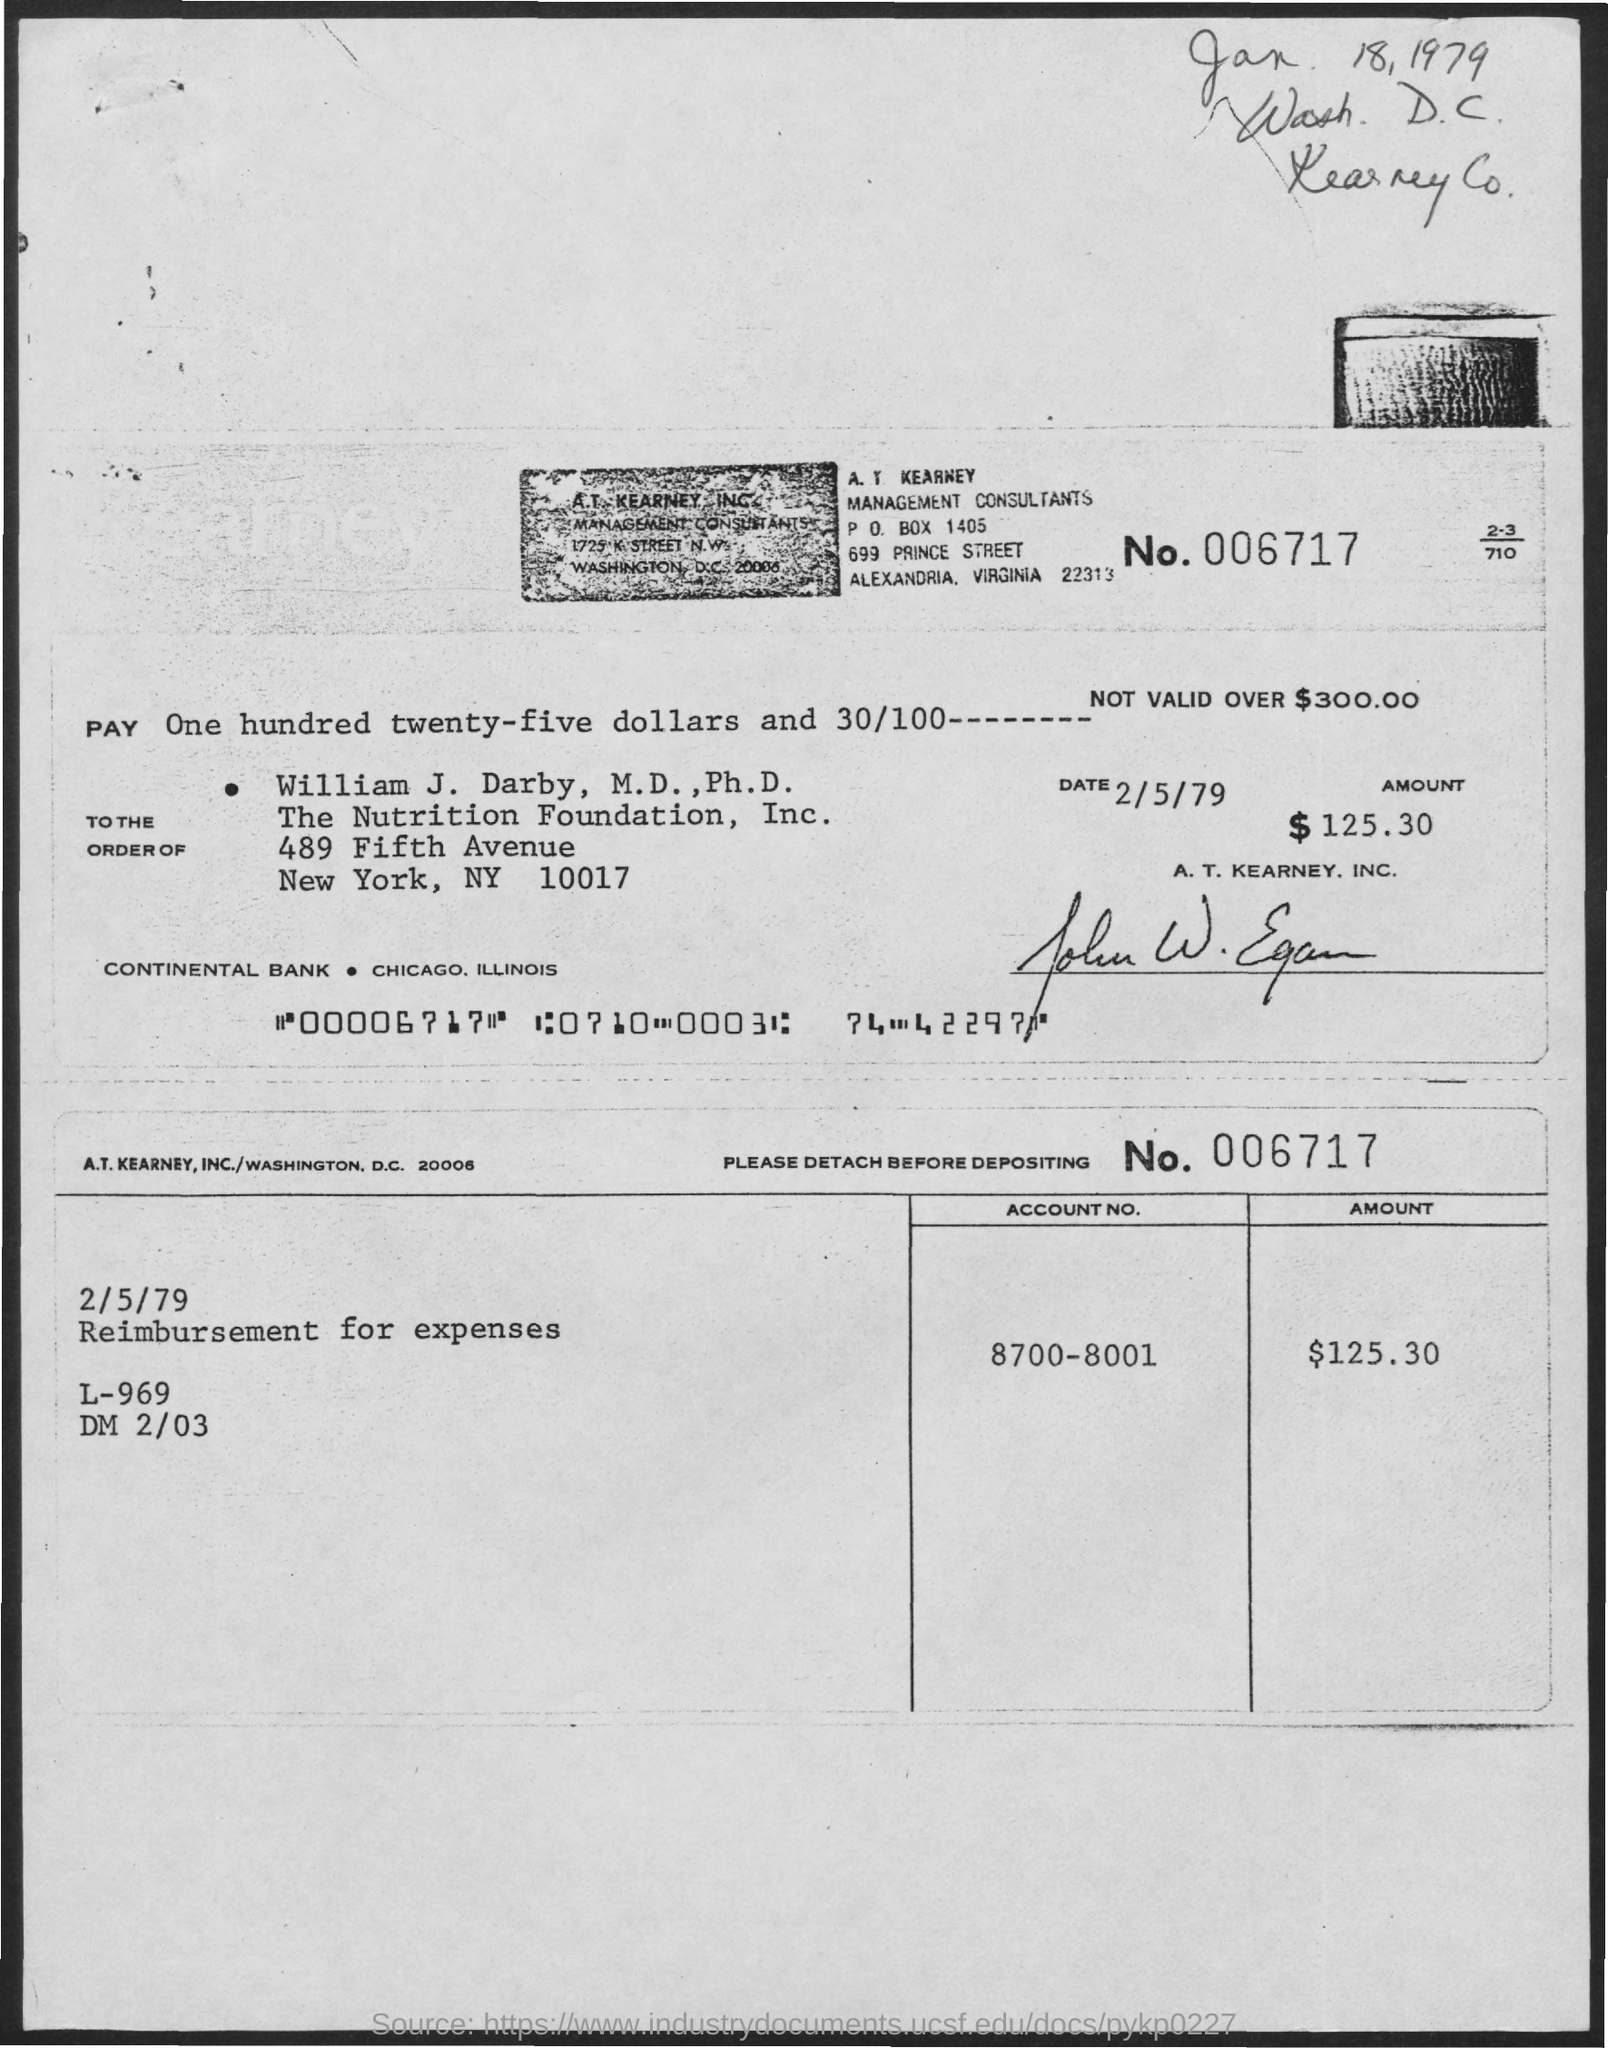Give some essential details in this illustration. The PO Box number mentioned in the document is p. o. box 1405. The account number is 8700-8001. The amount is $125.30. The number is 006717... 